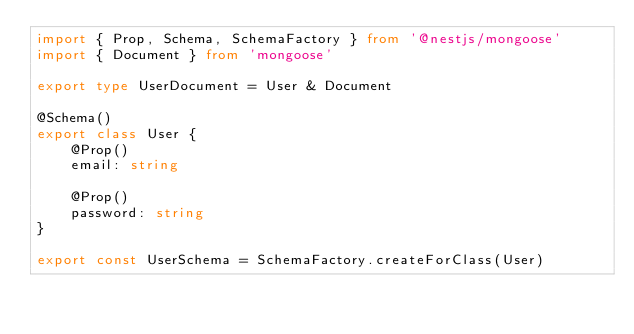Convert code to text. <code><loc_0><loc_0><loc_500><loc_500><_TypeScript_>import { Prop, Schema, SchemaFactory } from '@nestjs/mongoose'
import { Document } from 'mongoose'

export type UserDocument = User & Document

@Schema()
export class User {
    @Prop()
    email: string

    @Prop()
    password: string
}

export const UserSchema = SchemaFactory.createForClass(User)
</code> 